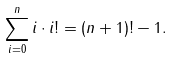Convert formula to latex. <formula><loc_0><loc_0><loc_500><loc_500>\sum _ { i = 0 } ^ { n } { i \cdot i ! } = { ( n + 1 ) ! } - 1 .</formula> 